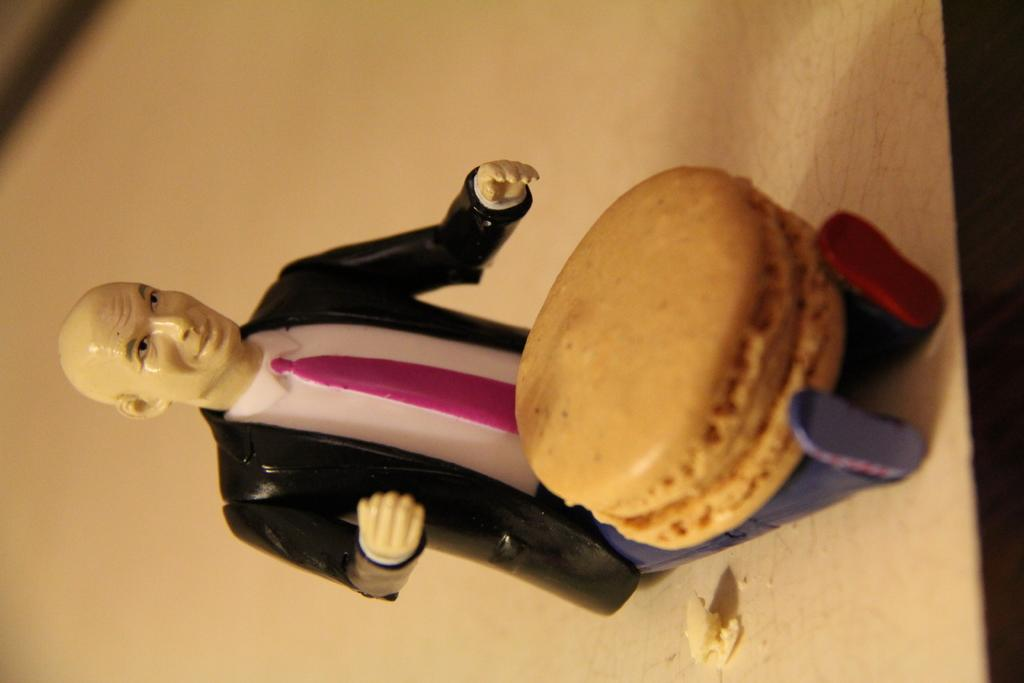What type of object can be seen in the image? There is a toy in the image. What edible item is present in the image? There is a biscuit in the image. What color is the surface the objects are on? The surface the objects are on is white. What type of laborer is working in the image? There is no laborer present in the image. What is the name of the daughter in the image? There is no daughter present in the image. 